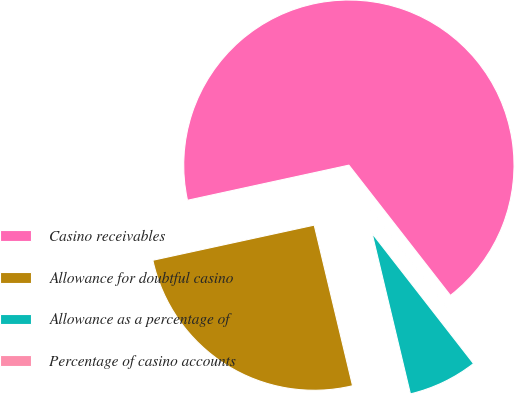<chart> <loc_0><loc_0><loc_500><loc_500><pie_chart><fcel>Casino receivables<fcel>Allowance for doubtful casino<fcel>Allowance as a percentage of<fcel>Percentage of casino accounts<nl><fcel>67.88%<fcel>25.32%<fcel>6.8%<fcel>0.01%<nl></chart> 